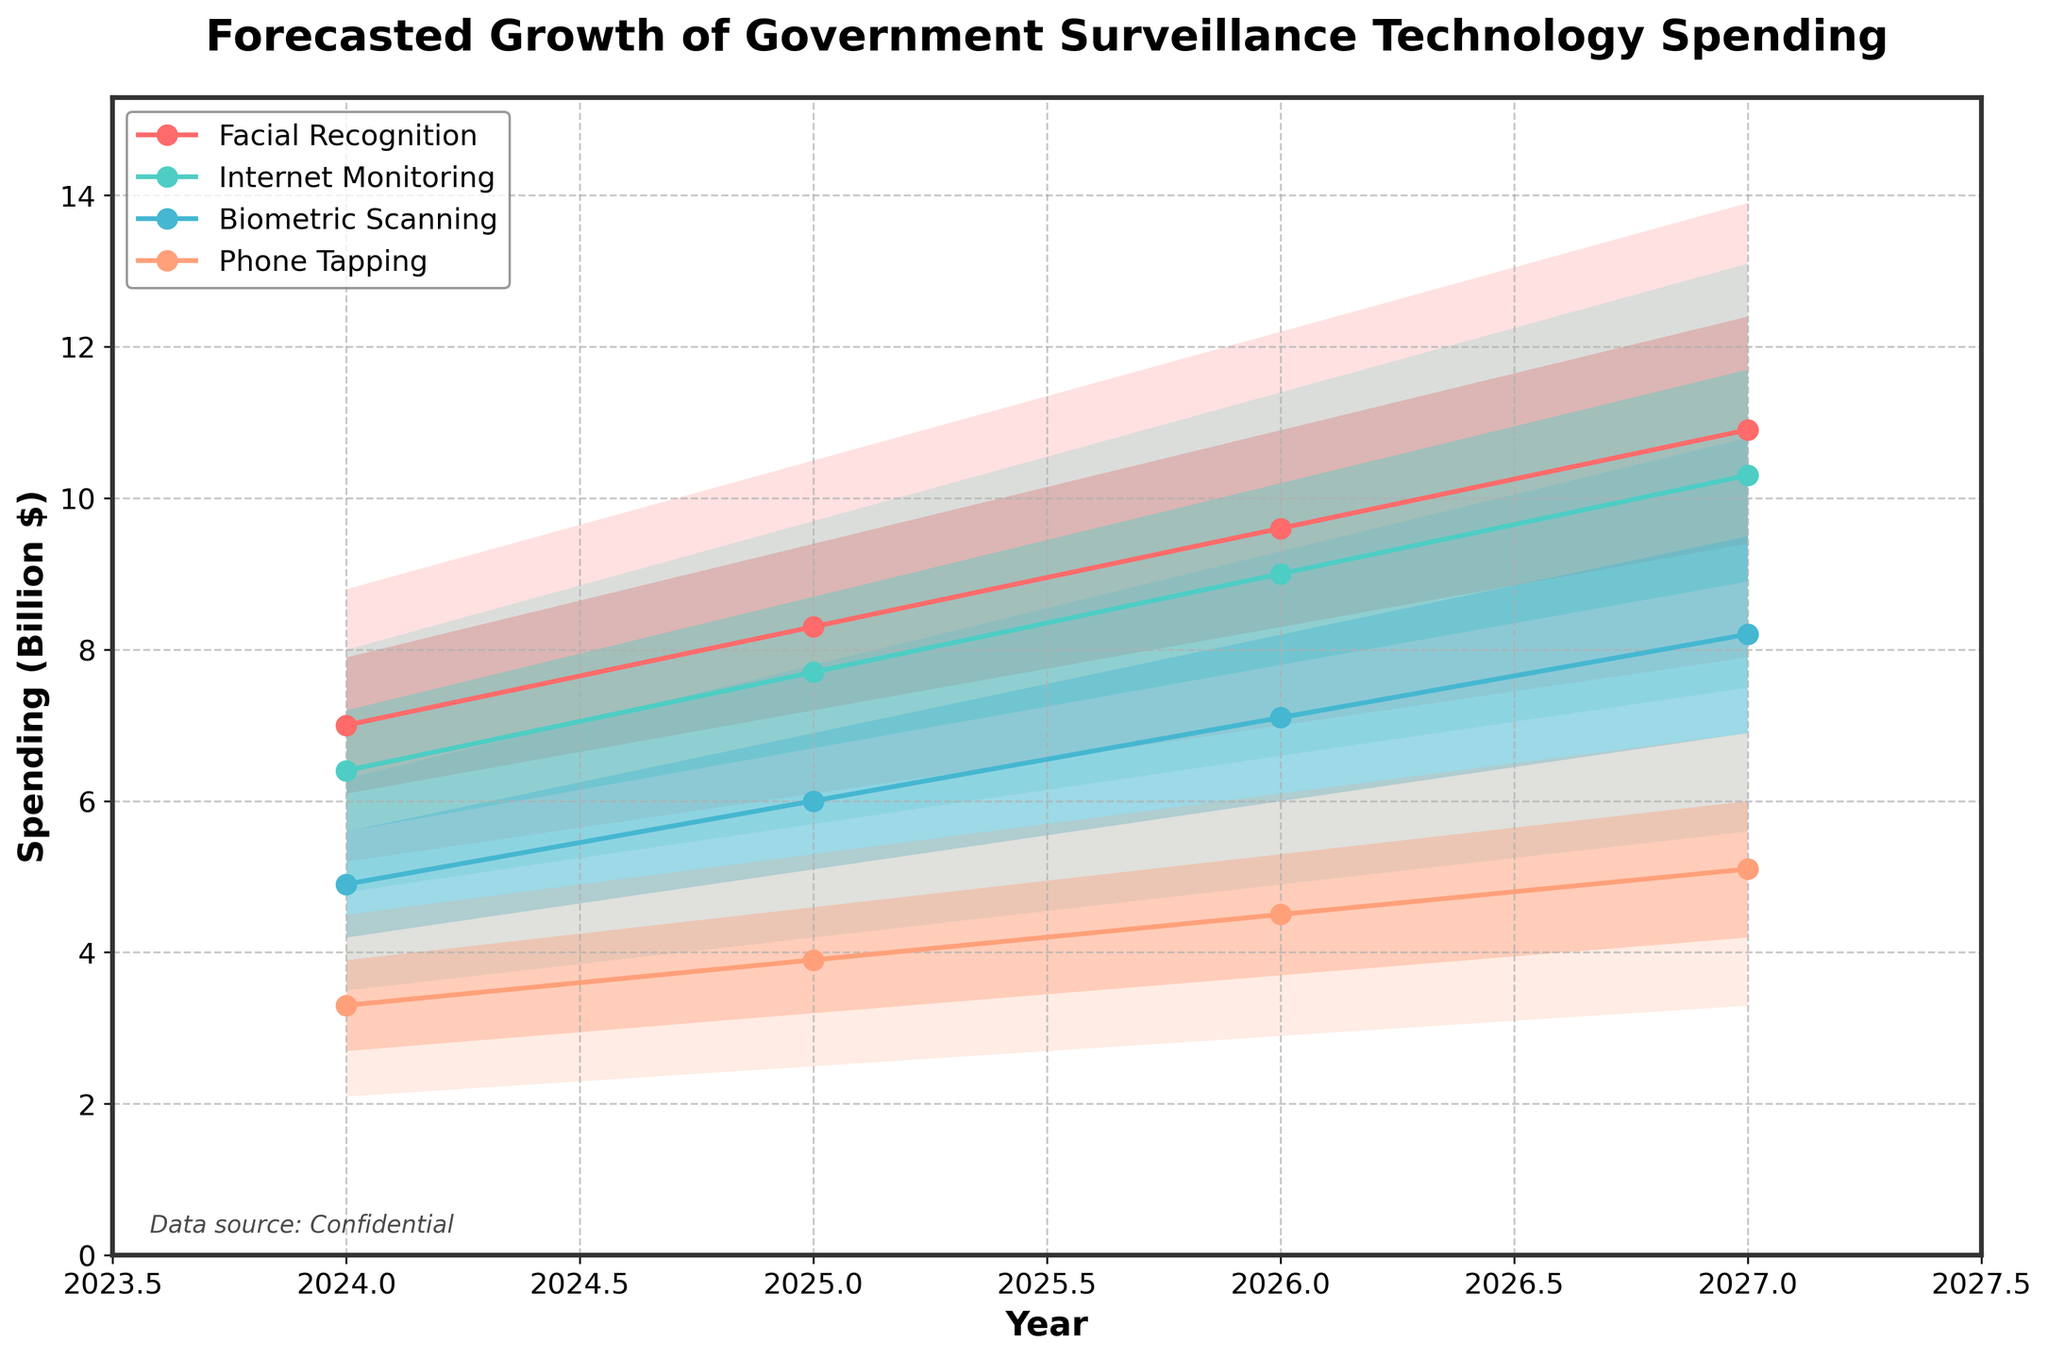What does the title of the figure indicate? The title of the figure provides an overview of what the chart represents. In this case, it is 'Forecasted Growth of Government Surveillance Technology Spending,' which means the figure shows the predicted future spending on different government surveillance technologies.
Answer: Forecasted Growth of Government Surveillance Technology Spending How is the spending forecasted for Facial Recognition for the year 2026 represented? For the year 2026, the forecasted spending on Facial Recognition is represented by a range (fan chart) with values from a low of 7.0, low-mid of 8.3, mid-average of 9.6, mid-high of 10.9, and a high of 12.2 billion dollars. These values indicate the uncertainty and possible variability in the forecast.
Answer: 7.0 - 12.2 billion dollars Which surveillance technology is predicted to have the highest median spending in 2027? To determine the highest median spending in 2027, examine the 'Mid' values for each category in that year. Facial Recognition has the highest median spending forecast at 10.9 billion dollars in 2027.
Answer: Facial Recognition Comparing 2024 and 2027, which surveillance method shows the largest projected increase in median spending? Analyze the 'Mid' values for 2024 and 2027 for each method: 
- Facial Recognition: 7.0 to 10.9 (3.9 billion increase)
- Internet Monitoring: 6.4 to 10.3 (3.9 billion increase)
- Biometric Scanning: 4.9 to 8.2 (3.3 billion increase)
- Phone Tapping: 3.3 to 5.1 (1.8 billion increase)  
Facial Recognition and Internet Monitoring both show the largest increase in median spending, each growing by 3.9 billion dollars.
Answer: Facial Recognition and Internet Monitoring What is the trend in the range of spending forecasts for Phone Tapping from 2024 to 2027? Looking at the low and high values for Phone Tapping:
- 2024: 2.1 to 4.5 billion dollars
- 2025: 2.5 to 5.3 billion dollars
- 2026: 2.9 to 6.1 billion dollars
- 2027: 3.3 to 6.9 billion dollars  
This shows an increasing trend both in the minimum and maximum forecasted spending values across the years.
Answer: Increasing trend How does the uncertainty in spending forecasts change over time for Biometric Scanning? Uncertainty can be assessed by the width of the fan chart (difference between high and low values) for Biometric Scanning over the years:
- 2024: 6.3 - 3.5 = 2.8 billion dollars
- 2025: 7.8 - 4.2 = 3.6 billion dollars
- 2026: 9.3 - 4.9 = 4.4 billion dollars
- 2027: 10.8 - 5.6 = 5.2 billion dollars  
The range of possible outcomes increases, indicating growing uncertainty in the forecasts over time.
Answer: Increasing uncertainty In 2025, which method has the closest range between the low and high forecasted spending values? Calculate the range (high - low) for each method in 2025:
- Facial Recognition: 10.5 - 6.1 = 4.4 billion dollars
- Internet Monitoring: 9.7 - 5.7 = 4.0 billion dollars
- Biometric Scanning: 7.8 - 4.2 = 3.6 billion dollars
- Phone Tapping: 5.3 - 2.5 = 2.8 billion dollars  
Phone Tapping has the closest range between the low and high forecasted spending values in 2025.
Answer: Phone Tapping Which method shows the most consistent increase in median spending over the years? Assess each method's median values ('Mid') over the years:
- Facial Recognition: 7.0, 8.3, 9.6, 10.9 (increasing consistently)
- Internet Monitoring: 6.4, 7.7, 9.0, 10.3 (increasing consistently)
- Biometric Scanning: 4.9, 6.0, 7.1, 8.2 (increasing consistently)
- Phone Tapping: 3.3, 3.9, 4.5, 5.1 (increasing consistently)  
All methods show a consistently increasing median trend.
Answer: All methods If the mid-high forecast for Biometric Scanning in 2027 is met, how much higher is it compared to the low forecast for the same method that year? Look at the mid-high and low values for Biometric Scanning in 2027:
- Mid-high: 9.5
- Low: 5.6  
The difference is: 9.5 - 5.6 = 3.9 billion dollars.
Answer: 3.9 billion dollars 